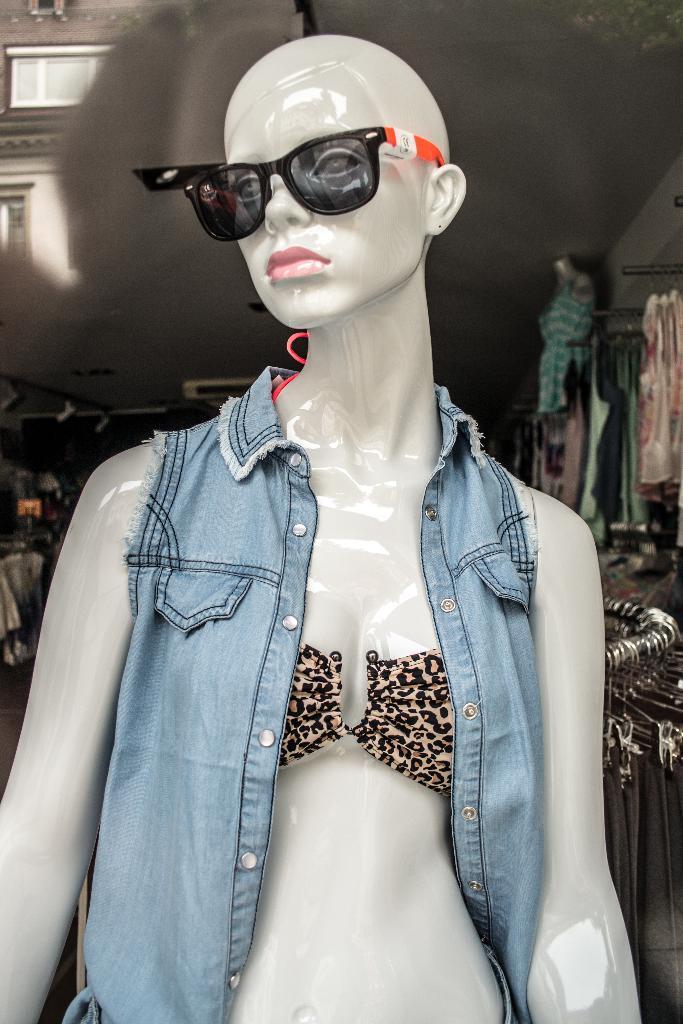Can you describe this image briefly? In the foreground of this image, there is a mannequin and also a spectacles to it. In the background, there are few clothes hanging and the ceiling. 